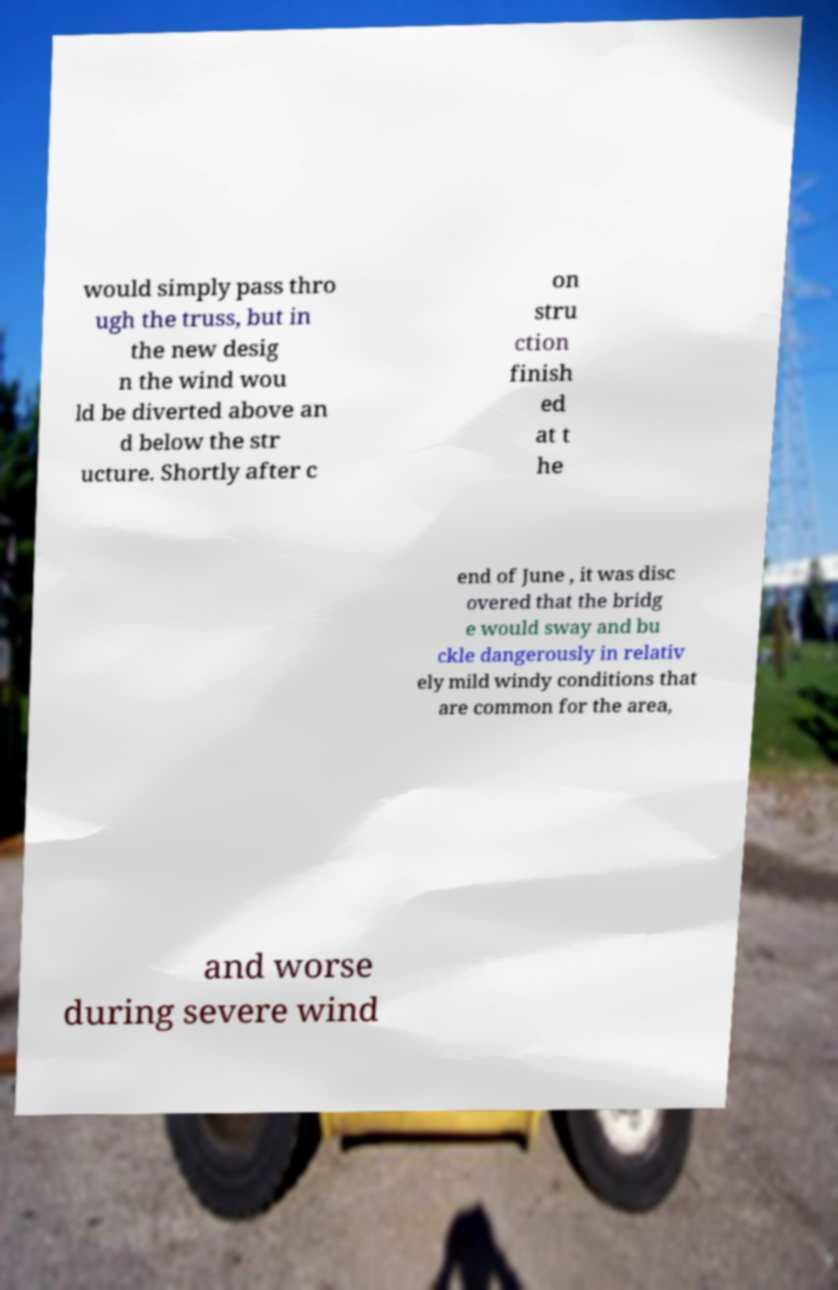There's text embedded in this image that I need extracted. Can you transcribe it verbatim? would simply pass thro ugh the truss, but in the new desig n the wind wou ld be diverted above an d below the str ucture. Shortly after c on stru ction finish ed at t he end of June , it was disc overed that the bridg e would sway and bu ckle dangerously in relativ ely mild windy conditions that are common for the area, and worse during severe wind 